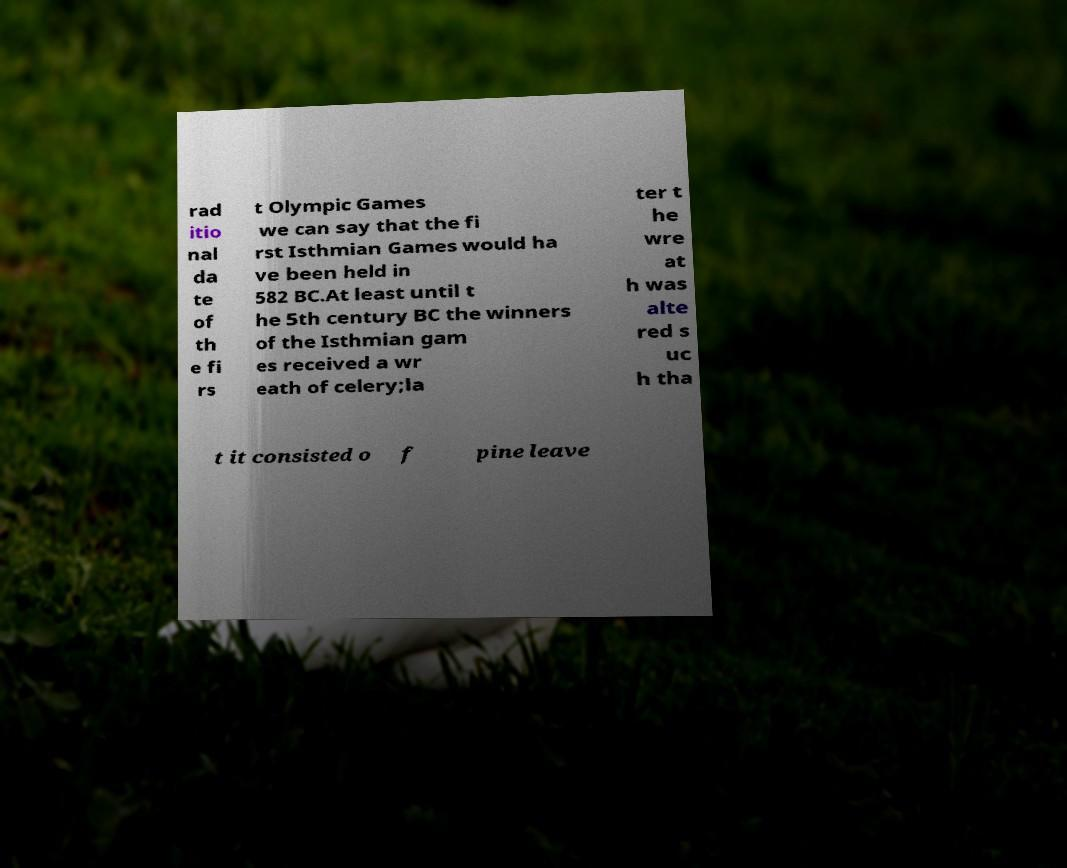Can you read and provide the text displayed in the image?This photo seems to have some interesting text. Can you extract and type it out for me? rad itio nal da te of th e fi rs t Olympic Games we can say that the fi rst Isthmian Games would ha ve been held in 582 BC.At least until t he 5th century BC the winners of the Isthmian gam es received a wr eath of celery;la ter t he wre at h was alte red s uc h tha t it consisted o f pine leave 